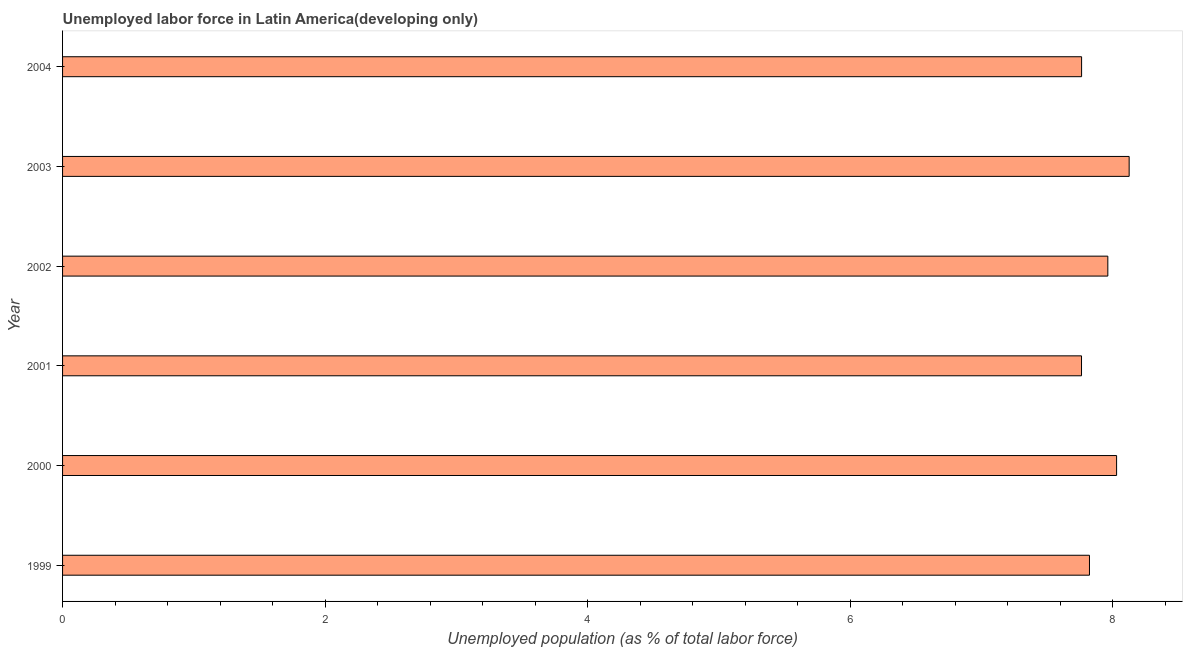Does the graph contain grids?
Your answer should be very brief. No. What is the title of the graph?
Give a very brief answer. Unemployed labor force in Latin America(developing only). What is the label or title of the X-axis?
Ensure brevity in your answer.  Unemployed population (as % of total labor force). What is the label or title of the Y-axis?
Keep it short and to the point. Year. What is the total unemployed population in 2001?
Provide a short and direct response. 7.76. Across all years, what is the maximum total unemployed population?
Provide a succinct answer. 8.12. Across all years, what is the minimum total unemployed population?
Offer a terse response. 7.76. What is the sum of the total unemployed population?
Your response must be concise. 47.46. What is the difference between the total unemployed population in 2001 and 2004?
Make the answer very short. -0. What is the average total unemployed population per year?
Offer a very short reply. 7.91. What is the median total unemployed population?
Provide a succinct answer. 7.89. In how many years, is the total unemployed population greater than 5.2 %?
Provide a short and direct response. 6. Is the total unemployed population in 2000 less than that in 2002?
Give a very brief answer. No. What is the difference between the highest and the second highest total unemployed population?
Your response must be concise. 0.1. Is the sum of the total unemployed population in 2001 and 2003 greater than the maximum total unemployed population across all years?
Offer a very short reply. Yes. What is the difference between the highest and the lowest total unemployed population?
Provide a short and direct response. 0.36. In how many years, is the total unemployed population greater than the average total unemployed population taken over all years?
Offer a very short reply. 3. How many years are there in the graph?
Your answer should be very brief. 6. What is the difference between two consecutive major ticks on the X-axis?
Give a very brief answer. 2. Are the values on the major ticks of X-axis written in scientific E-notation?
Your answer should be very brief. No. What is the Unemployed population (as % of total labor force) of 1999?
Provide a succinct answer. 7.82. What is the Unemployed population (as % of total labor force) in 2000?
Offer a very short reply. 8.03. What is the Unemployed population (as % of total labor force) of 2001?
Your answer should be very brief. 7.76. What is the Unemployed population (as % of total labor force) of 2002?
Ensure brevity in your answer.  7.96. What is the Unemployed population (as % of total labor force) in 2003?
Provide a short and direct response. 8.12. What is the Unemployed population (as % of total labor force) in 2004?
Your response must be concise. 7.76. What is the difference between the Unemployed population (as % of total labor force) in 1999 and 2000?
Ensure brevity in your answer.  -0.21. What is the difference between the Unemployed population (as % of total labor force) in 1999 and 2001?
Make the answer very short. 0.06. What is the difference between the Unemployed population (as % of total labor force) in 1999 and 2002?
Keep it short and to the point. -0.14. What is the difference between the Unemployed population (as % of total labor force) in 1999 and 2003?
Your answer should be compact. -0.3. What is the difference between the Unemployed population (as % of total labor force) in 1999 and 2004?
Give a very brief answer. 0.06. What is the difference between the Unemployed population (as % of total labor force) in 2000 and 2001?
Provide a succinct answer. 0.27. What is the difference between the Unemployed population (as % of total labor force) in 2000 and 2002?
Your answer should be very brief. 0.07. What is the difference between the Unemployed population (as % of total labor force) in 2000 and 2003?
Provide a short and direct response. -0.1. What is the difference between the Unemployed population (as % of total labor force) in 2000 and 2004?
Provide a succinct answer. 0.27. What is the difference between the Unemployed population (as % of total labor force) in 2001 and 2002?
Ensure brevity in your answer.  -0.2. What is the difference between the Unemployed population (as % of total labor force) in 2001 and 2003?
Your answer should be very brief. -0.36. What is the difference between the Unemployed population (as % of total labor force) in 2001 and 2004?
Provide a succinct answer. -0. What is the difference between the Unemployed population (as % of total labor force) in 2002 and 2003?
Offer a terse response. -0.16. What is the difference between the Unemployed population (as % of total labor force) in 2002 and 2004?
Ensure brevity in your answer.  0.2. What is the difference between the Unemployed population (as % of total labor force) in 2003 and 2004?
Your response must be concise. 0.36. What is the ratio of the Unemployed population (as % of total labor force) in 1999 to that in 2002?
Your answer should be very brief. 0.98. What is the ratio of the Unemployed population (as % of total labor force) in 1999 to that in 2003?
Offer a very short reply. 0.96. What is the ratio of the Unemployed population (as % of total labor force) in 1999 to that in 2004?
Provide a short and direct response. 1.01. What is the ratio of the Unemployed population (as % of total labor force) in 2000 to that in 2001?
Keep it short and to the point. 1.03. What is the ratio of the Unemployed population (as % of total labor force) in 2000 to that in 2004?
Make the answer very short. 1.03. What is the ratio of the Unemployed population (as % of total labor force) in 2001 to that in 2002?
Make the answer very short. 0.97. What is the ratio of the Unemployed population (as % of total labor force) in 2001 to that in 2003?
Offer a terse response. 0.95. What is the ratio of the Unemployed population (as % of total labor force) in 2002 to that in 2004?
Your answer should be very brief. 1.03. What is the ratio of the Unemployed population (as % of total labor force) in 2003 to that in 2004?
Provide a short and direct response. 1.05. 